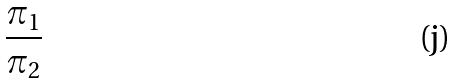Convert formula to latex. <formula><loc_0><loc_0><loc_500><loc_500>\frac { \pi _ { 1 } } { \pi _ { 2 } }</formula> 